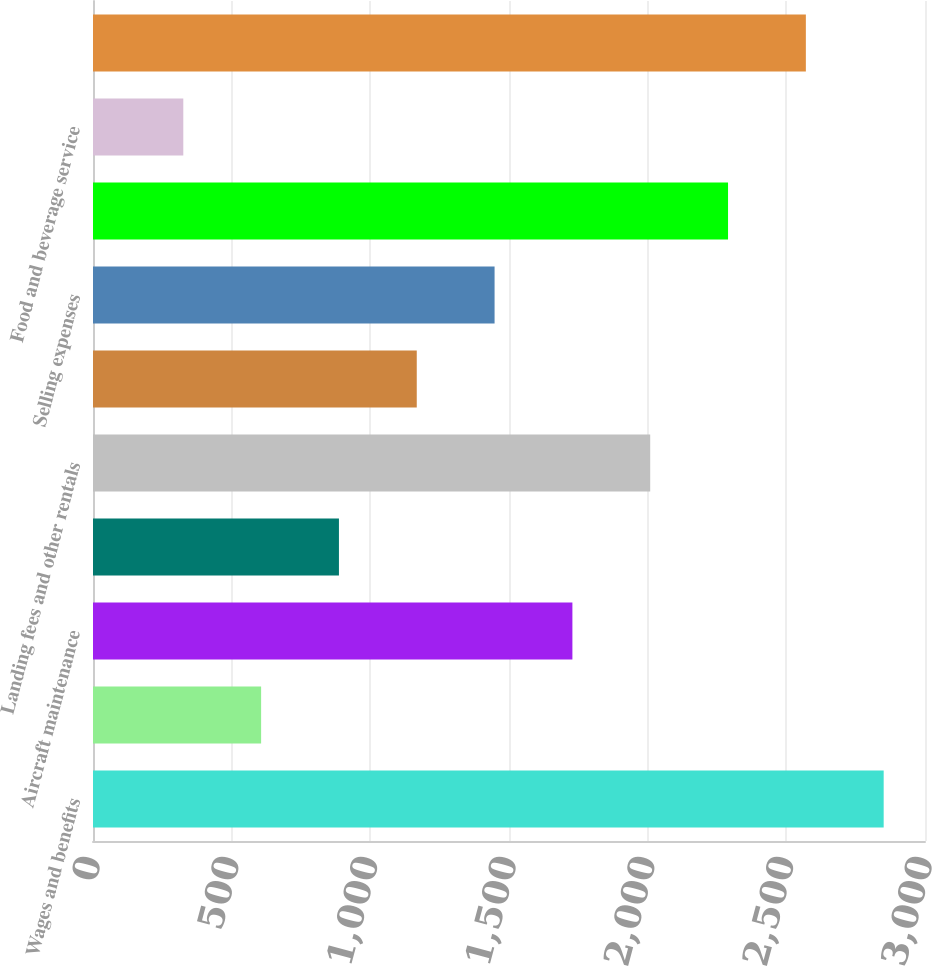Convert chart to OTSL. <chart><loc_0><loc_0><loc_500><loc_500><bar_chart><fcel>Wages and benefits<fcel>Variable incentive pay<fcel>Aircraft maintenance<fcel>Aircraft rent<fcel>Landing fees and other rentals<fcel>Contracted services<fcel>Selling expenses<fcel>Depreciation and amortization<fcel>Food and beverage service<fcel>Other<nl><fcel>2851<fcel>606.2<fcel>1728.6<fcel>886.8<fcel>2009.2<fcel>1167.4<fcel>1448<fcel>2289.8<fcel>325.6<fcel>2570.4<nl></chart> 